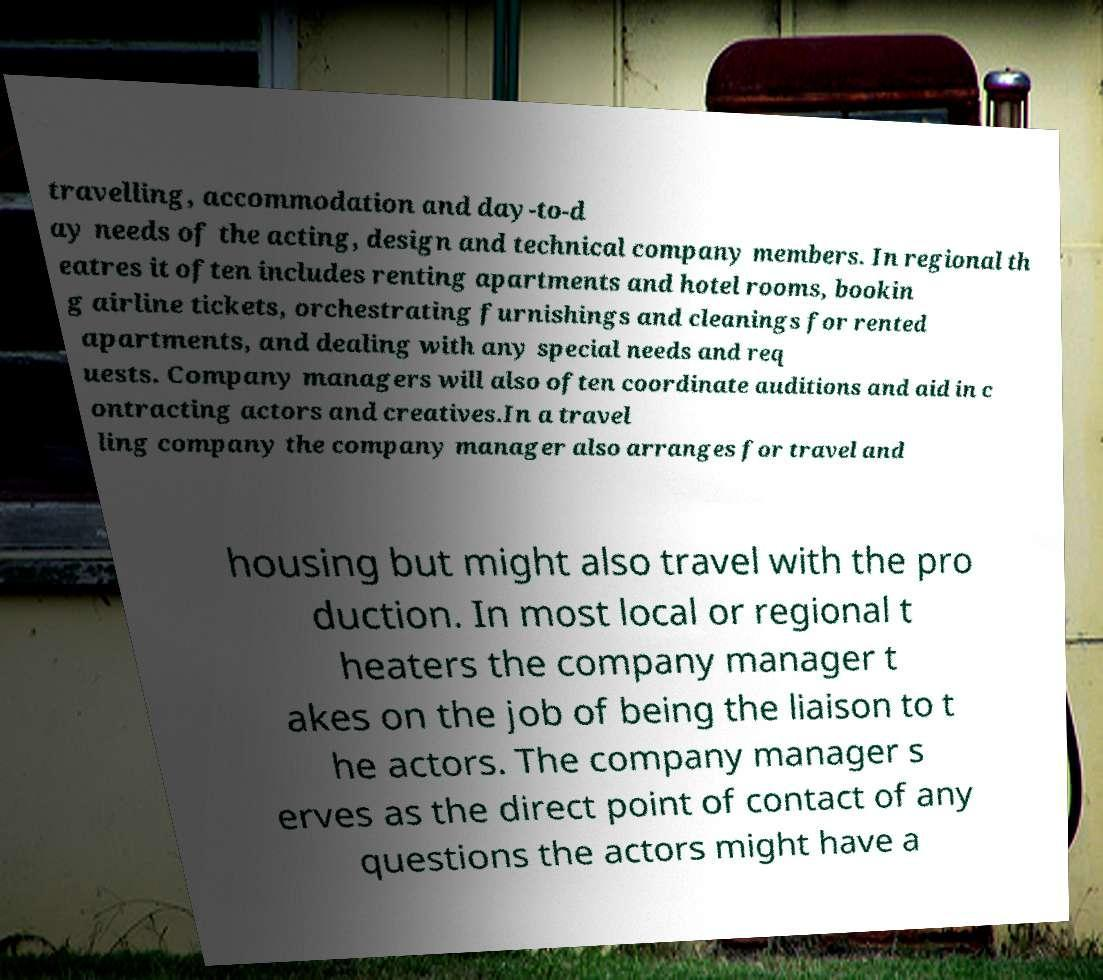For documentation purposes, I need the text within this image transcribed. Could you provide that? travelling, accommodation and day-to-d ay needs of the acting, design and technical company members. In regional th eatres it often includes renting apartments and hotel rooms, bookin g airline tickets, orchestrating furnishings and cleanings for rented apartments, and dealing with any special needs and req uests. Company managers will also often coordinate auditions and aid in c ontracting actors and creatives.In a travel ling company the company manager also arranges for travel and housing but might also travel with the pro duction. In most local or regional t heaters the company manager t akes on the job of being the liaison to t he actors. The company manager s erves as the direct point of contact of any questions the actors might have a 